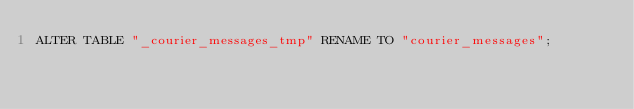<code> <loc_0><loc_0><loc_500><loc_500><_SQL_>ALTER TABLE "_courier_messages_tmp" RENAME TO "courier_messages";</code> 